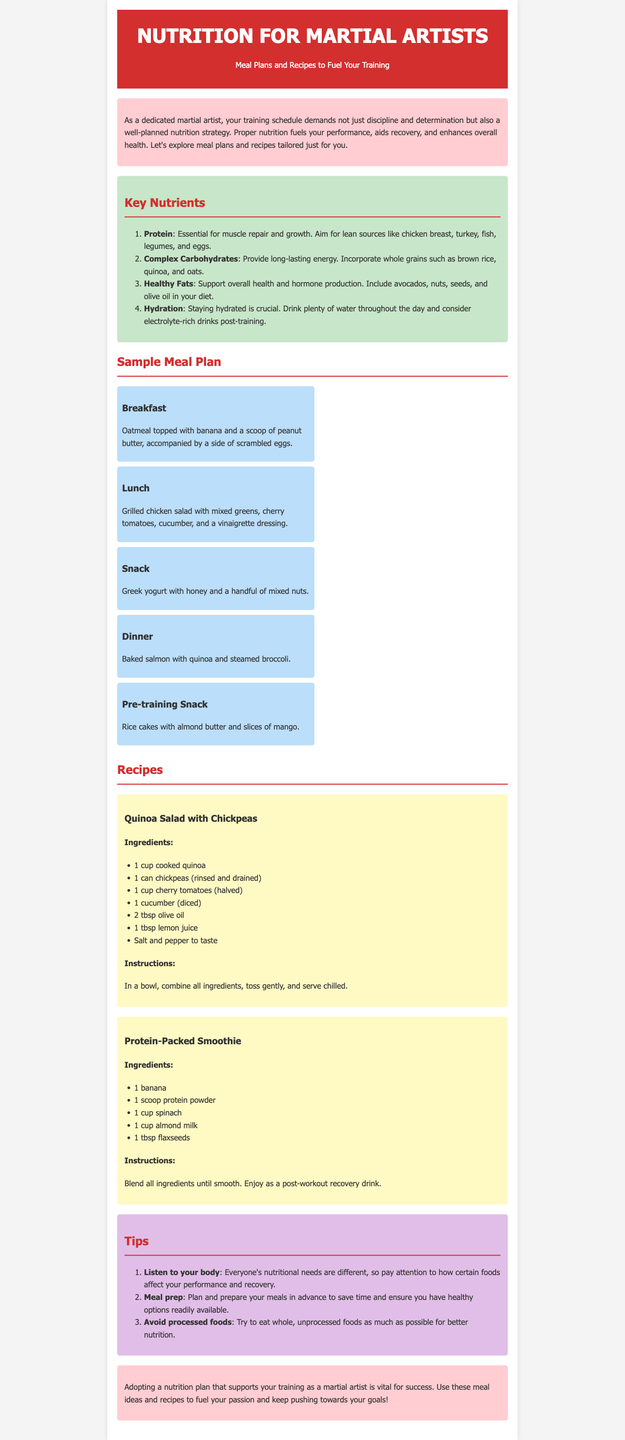What are the four key nutrients mentioned? The document lists the key nutrients essential for martial artists, which are protein, complex carbohydrates, healthy fats, and hydration.
Answer: Protein, complex carbohydrates, healthy fats, hydration What is the breakfast meal plan? The breakfast meal plan includes oatmeal topped with banana and a scoop of peanut butter, accompanied by a side of scrambled eggs.
Answer: Oatmeal topped with banana and a scoop of peanut butter, scrambled eggs What is one recipe provided in the newsletter? The document contains two recipes, one of which is Quinoa Salad with Chickpeas.
Answer: Quinoa Salad with Chickpeas How many meals are included in the sample meal plan? The meal plan includes a total of five meals: breakfast, lunch, snack, dinner, and pre-training snack.
Answer: Five What should martial artists avoid in their diet? The document advises martial artists to avoid processed foods to maintain better nutrition.
Answer: Processed foods What is the instruction for the Protein-Packed Smoothie? The instructions for the Protein-Packed Smoothie specify to blend all ingredients until smooth.
Answer: Blend all ingredients until smooth How can meal prep benefit martial artists? The newsletter suggests that meal prep helps in planning and preparing meals in advance, saving time and ensuring healthy options are readily available.
Answer: Saves time, ensures healthy options What is the purpose of proper nutrition according to the document? The purpose of proper nutrition, as stated in the document, is to fuel your performance, aid recovery, and enhance overall health.
Answer: Fuel performance, aid recovery, enhance overall health 